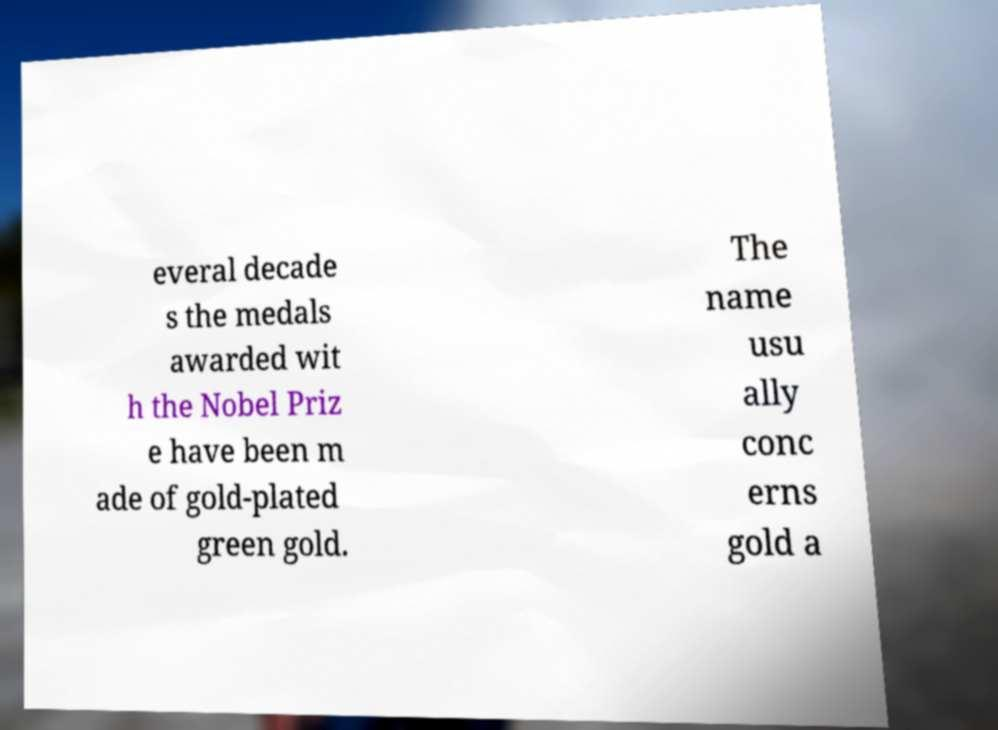Could you extract and type out the text from this image? everal decade s the medals awarded wit h the Nobel Priz e have been m ade of gold-plated green gold. The name usu ally conc erns gold a 